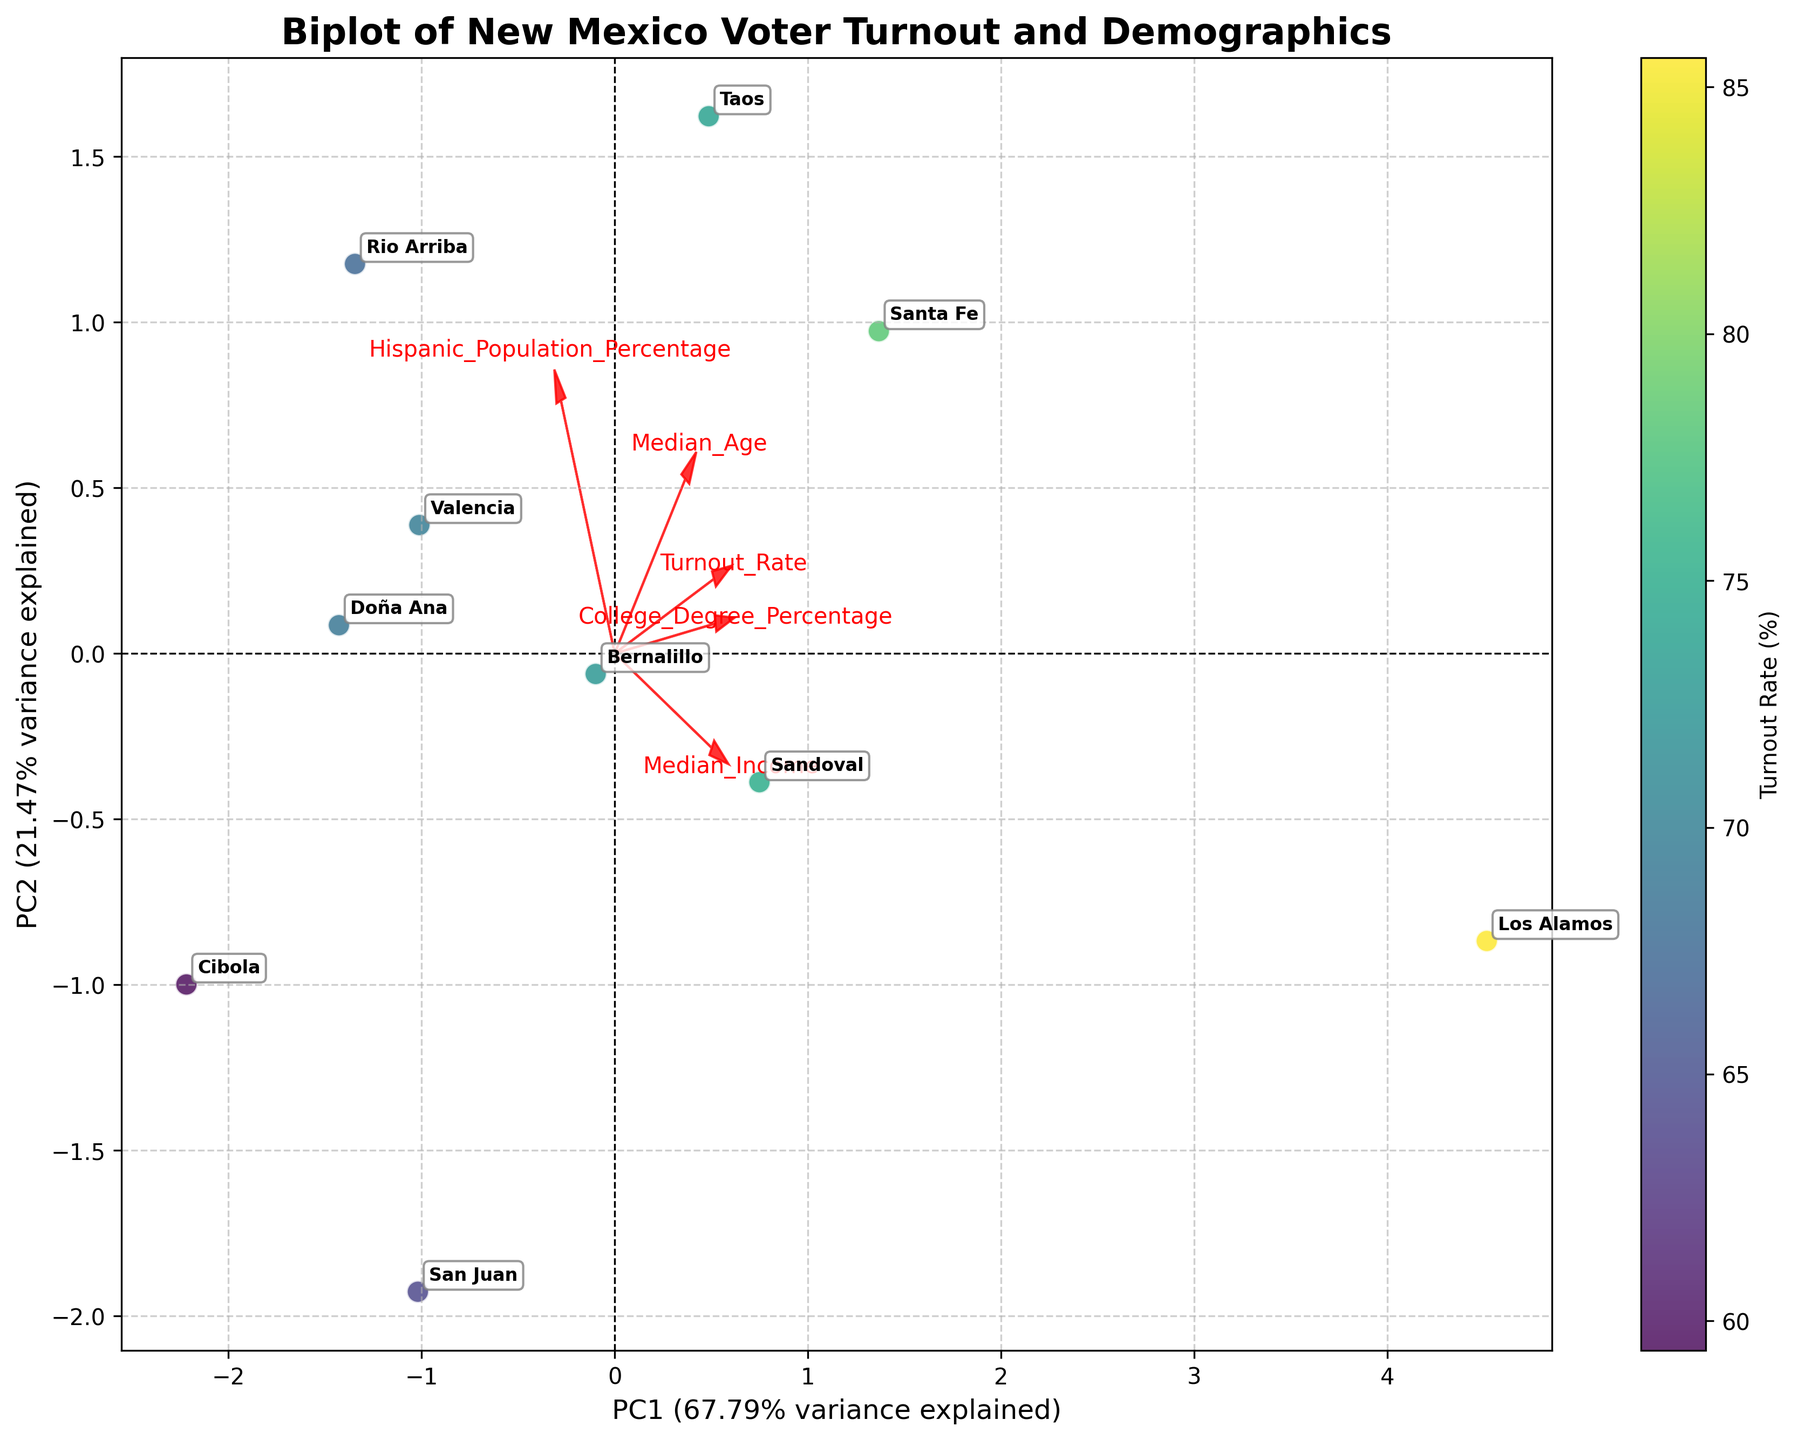How much of the variance is explained by the first principal component (PC1)? The x-axis label provides this information. The label indicates the percentage of variance explained by PC1.
Answer: Approximately 58.5% Which county has the highest voter turnout rate? Look for the data point with the highest value on the color scale (yellow) and check the annotated label.
Answer: Los Alamos Between which two counties is the second principal component (PC2) most significantly different? Look for the counties that are furthest apart vertically on the y-axis. Examine the annotated labels for these points.
Answer: Cibola and Taos Among the demographic factors, which feature aligns most closely with PC1? Look at the red arrows representing demographic factors and see which one is most aligned with the x-axis (PC1).
Answer: Median Income Is there a trend between voter turnout rate and Hispanic population percentage? Observe the angle and direction of the arrow representing the Hispanic population percentage relative to the turnout rate. If they point in similar directions, there's a positive correlation; if they point in opposite directions, there's a negative correlation.
Answer: Negative correlation What county is closest to the average in both principal components? Find the data point nearest to the origin (0,0) of the biplot since this represents the average in PCA space. Check the annotated label for this point.
Answer: San Juan Do higher college degree percentages correlate more with PC1 or PC2? Observe the angle of the arrow representing the college degree percentage. This will show the primary dimension (PC1 or PC2) with which it aligns more closely.
Answer: PC1 Which county is represented furthest to the right on the biplot? Identify the point with the highest x-coordinate and check the annotated label.
Answer: Los Alamos If you wanted to understand how median age affects voter turnout, in which direction would you look on the biplot? Look at the direction of the arrow representing median age to understand how changes in this demographic factor correlate with voter turnout.
Answer: Diagonally up and right 